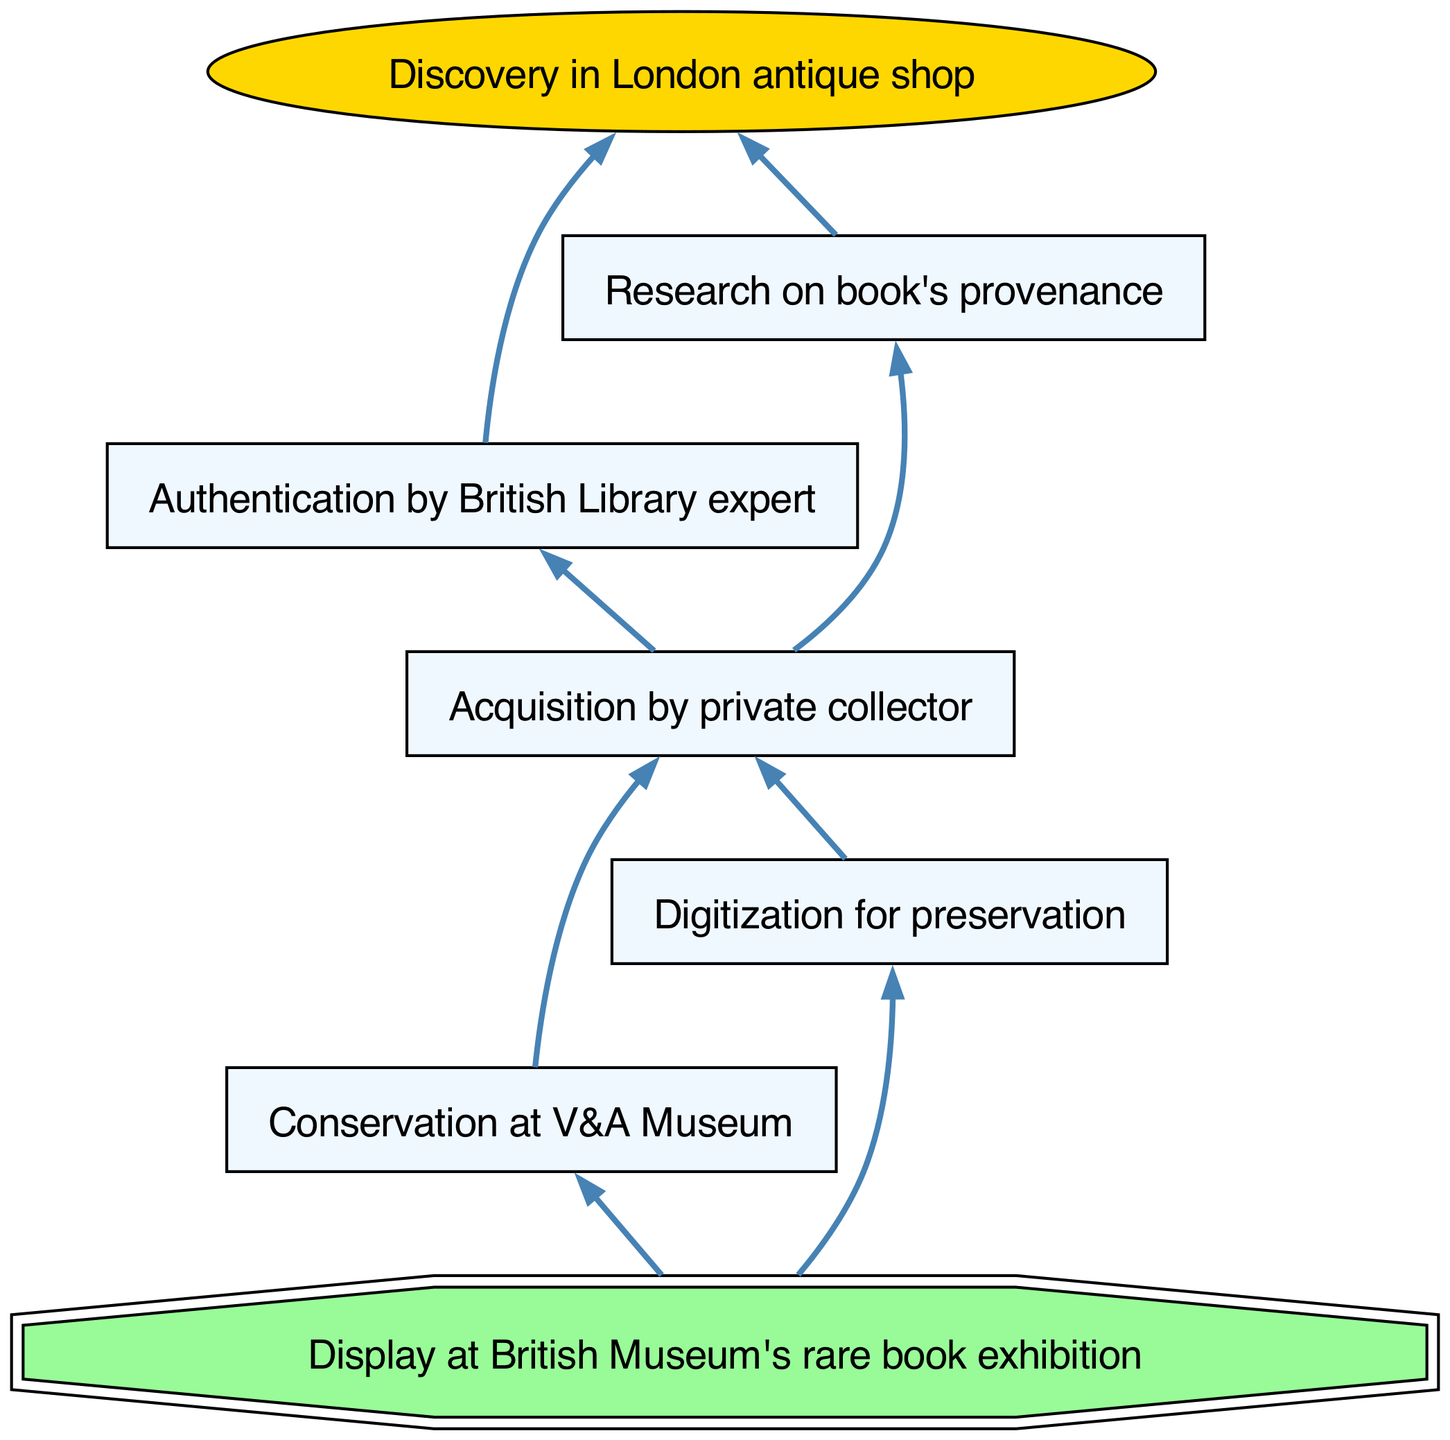What is the first step in the journey of a rare book? The first step in this journey is "Discovery in London antique shop," which is the starting node in the flow chart.
Answer: Discovery in London antique shop How many nodes are connected to the "Acquisition by private collector" node? The "Acquisition by private collector" node has two connections leading to "Conservation at V&A Museum" and "Digitization for preservation," which means it connects to two nodes.
Answer: 2 What is the final destination for the rare book in this diagram? The final node indicates the ultimate goal, which is "Display at British Museum's rare book exhibition," serving as the endpoint in the flow.
Answer: Display at British Museum's rare book exhibition What follows the "Research on book's provenance" step? From the "Research on book's provenance" node, the next step in the journey is "Acquisition by private collector," as indicated by the directed connection in the chart.
Answer: Acquisition by private collector Which process occurs after the conservation of the book? After the "Conservation at V&A Museum," there are two branches, including "Digitization for preservation," making it the next process that can be followed in one of the flows.
Answer: Digitization for preservation What is the relationship between the "Authentication by British Library expert" and "Research on book's provenance"? These two nodes are connected to the same next node, "Acquisition by private collector," indicating that both processes lead to the same outcome in the flow chart.
Answer: Both lead to Acquisition by private collector What is unique about the beginning and end of this diagram? The beginning node is shaped as an oval, indicating the start of the process, while the end node is shaped as a double octagon, signaling the conclusion of the journey represented in the flow chart.
Answer: Oval and double octagon How many steps are there from the "Discovery in London antique shop" to the final display? There are a total of six steps if we count each node from the starting point to the final display: "Discovery in London antique shop," "Authentication by British Library expert," "Research on book's provenance," "Acquisition by private collector," "Conservation at V&A Museum" or "Digitization for preservation," and finally "Display at British Museum's rare book exhibition."
Answer: 6 